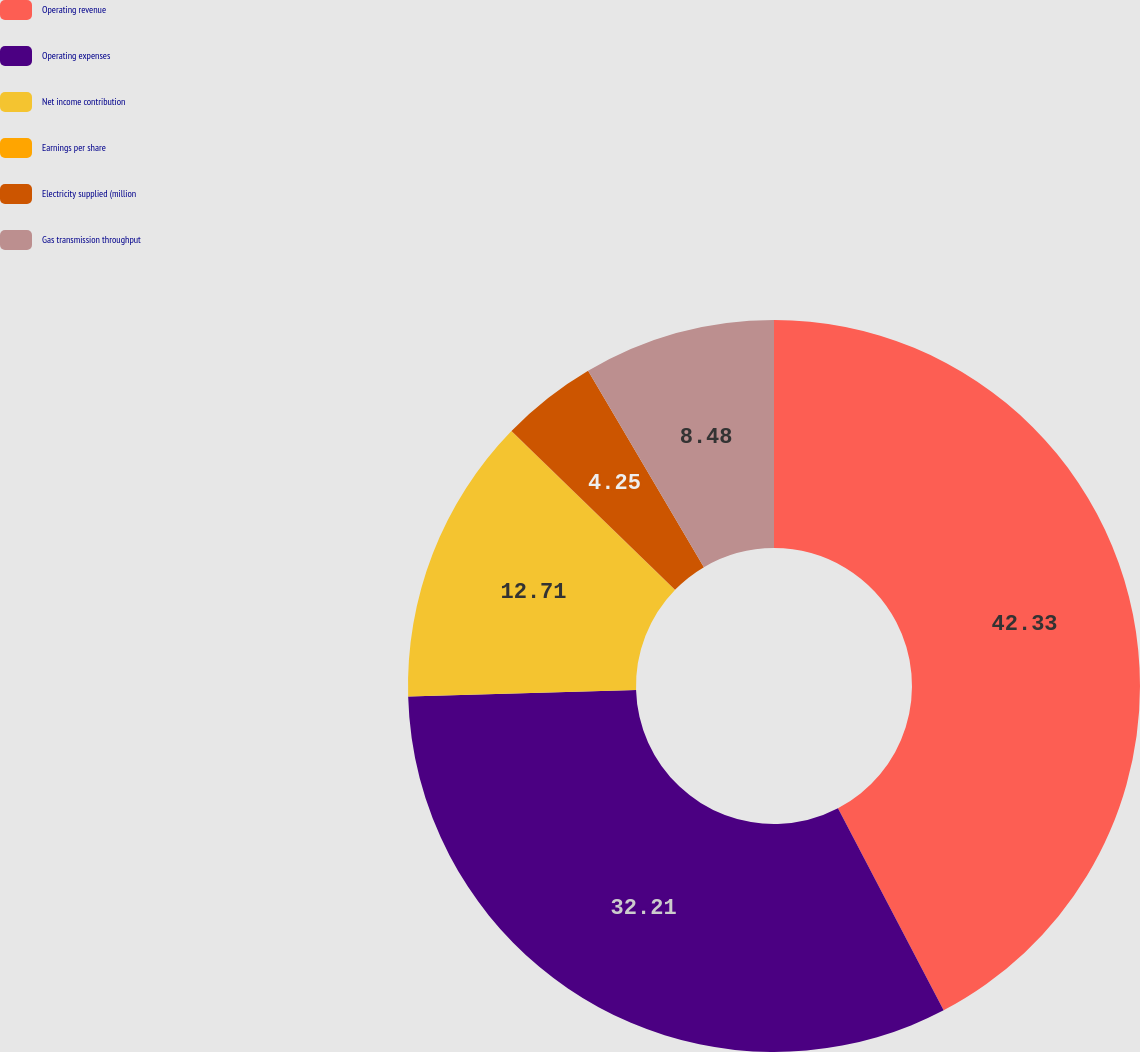Convert chart. <chart><loc_0><loc_0><loc_500><loc_500><pie_chart><fcel>Operating revenue<fcel>Operating expenses<fcel>Net income contribution<fcel>Earnings per share<fcel>Electricity supplied (million<fcel>Gas transmission throughput<nl><fcel>42.33%<fcel>32.21%<fcel>12.71%<fcel>0.02%<fcel>4.25%<fcel>8.48%<nl></chart> 